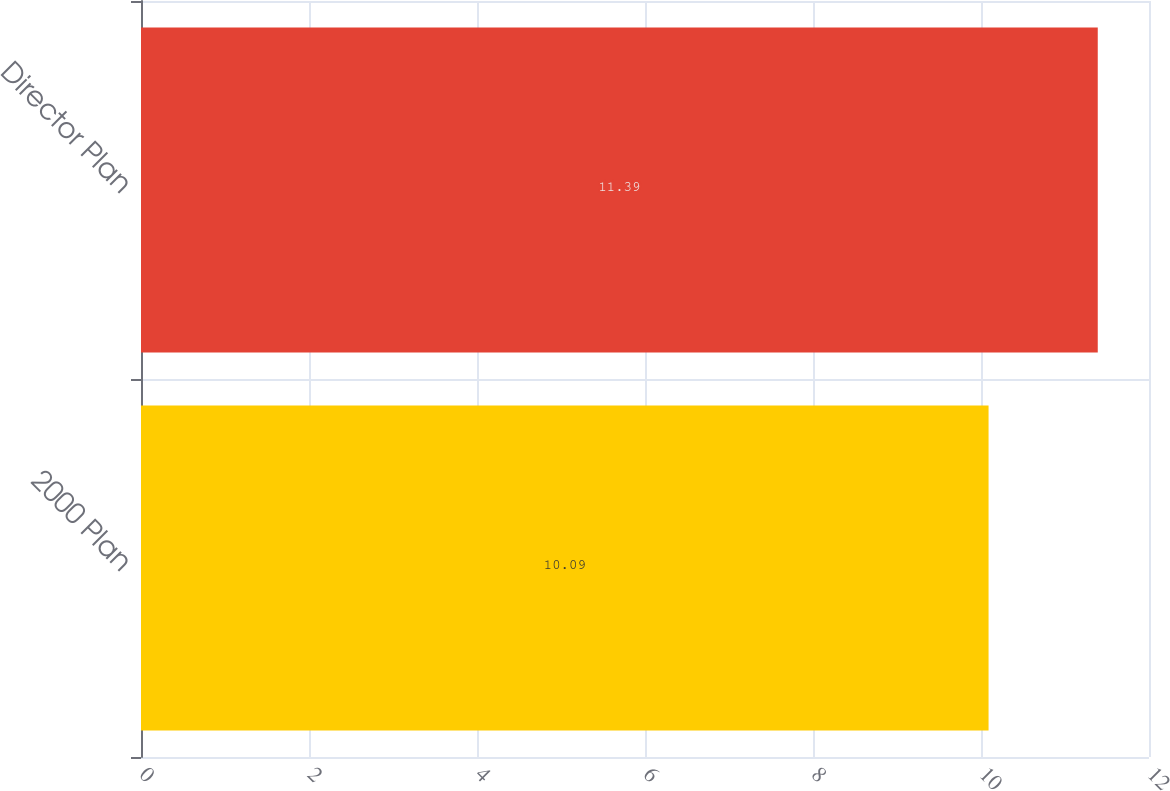Convert chart to OTSL. <chart><loc_0><loc_0><loc_500><loc_500><bar_chart><fcel>2000 Plan<fcel>Director Plan<nl><fcel>10.09<fcel>11.39<nl></chart> 